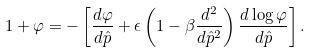<formula> <loc_0><loc_0><loc_500><loc_500>1 + { \varphi } = - \left [ \frac { d { \varphi } } { d \hat { p } } + \epsilon \left ( 1 - \beta \frac { d ^ { 2 } } { d { \hat { p } } ^ { 2 } } \right ) \frac { d \log { \varphi } } { d \hat { p } } \right ] .</formula> 